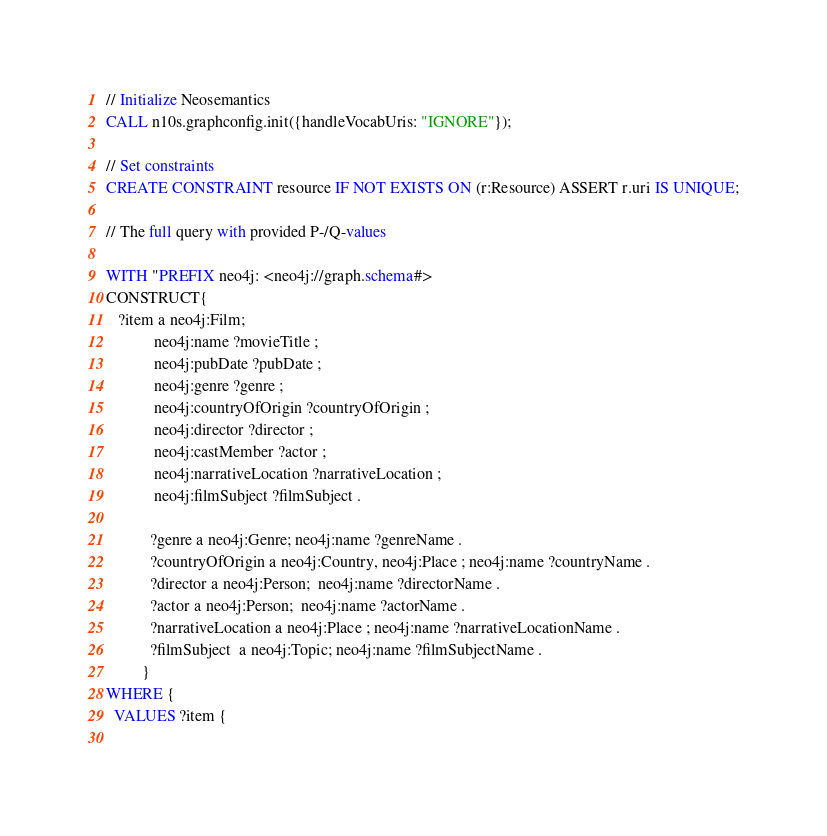Convert code to text. <code><loc_0><loc_0><loc_500><loc_500><_SQL_>// Initialize Neosemantics
CALL n10s.graphconfig.init({handleVocabUris: "IGNORE"});

// Set constraints
CREATE CONSTRAINT resource IF NOT EXISTS ON (r:Resource) ASSERT r.uri IS UNIQUE;

// The full query with provided P-/Q-values

WITH "PREFIX neo4j: <neo4j://graph.schema#> 
CONSTRUCT{ 
   ?item a neo4j:Film; 
            neo4j:name ?movieTitle ; 
            neo4j:pubDate ?pubDate ;  
            neo4j:genre ?genre ;
            neo4j:countryOfOrigin ?countryOfOrigin ;
            neo4j:director ?director ;
            neo4j:castMember ?actor ;
            neo4j:narrativeLocation ?narrativeLocation ;
            neo4j:filmSubject ?filmSubject .
           
           ?genre a neo4j:Genre; neo4j:name ?genreName .
           ?countryOfOrigin a neo4j:Country, neo4j:Place ; neo4j:name ?countryName .
           ?director a neo4j:Person;  neo4j:name ?directorName .          
           ?actor a neo4j:Person;  neo4j:name ?actorName .          
           ?narrativeLocation a neo4j:Place ; neo4j:name ?narrativeLocationName .          
           ?filmSubject  a neo4j:Topic; neo4j:name ?filmSubjectName .
         } 
WHERE { 
  VALUES ?item { 
    </code> 